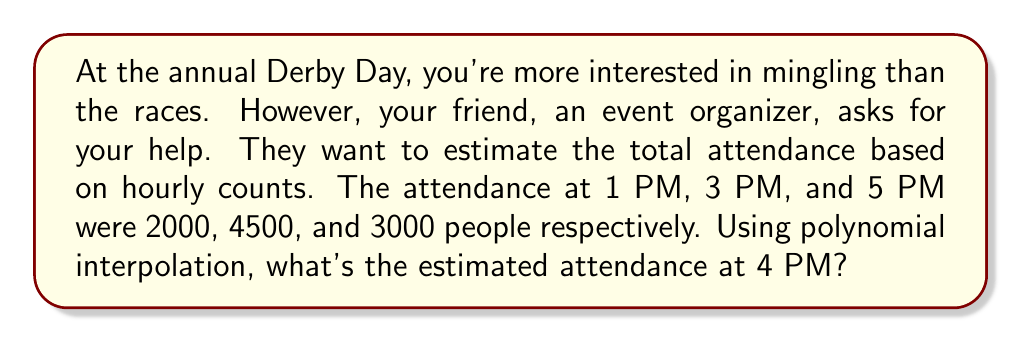Show me your answer to this math problem. Let's approach this step-by-step using polynomial interpolation:

1) We'll use a quadratic polynomial of the form $f(x) = ax^2 + bx + c$, where $x$ represents the time (with 1 PM as $x=0$, 3 PM as $x=2$, and 5 PM as $x=4$).

2) We have three data points:
   $f(0) = 2000$
   $f(2) = 4500$
   $f(4) = 3000$

3) Substituting these into our quadratic equation:
   $2000 = c$
   $4500 = 4a + 2b + c$
   $3000 = 16a + 4b + c$

4) From the first equation, we know $c = 2000$. Substituting this into the other two:
   $2500 = 4a + 2b$
   $1000 = 16a + 4b$

5) Multiply the first equation by 2:
   $5000 = 8a + 4b$
   $1000 = 16a + 4b$

6) Subtracting the second equation from the first:
   $4000 = -8a$
   $a = -500$

7) Substitute this back into $2500 = 4a + 2b$:
   $2500 = 4(-500) + 2b$
   $2500 = -2000 + 2b$
   $4500 = 2b$
   $b = 2250$

8) Now we have our quadratic function:
   $f(x) = -500x^2 + 2250x + 2000$

9) To find the attendance at 4 PM (which is $x=3$), we calculate:
   $f(3) = -500(3)^2 + 2250(3) + 2000$
   $     = -4500 + 6750 + 2000$
   $     = 4250$

Therefore, the estimated attendance at 4 PM is 4250 people.
Answer: 4250 people 